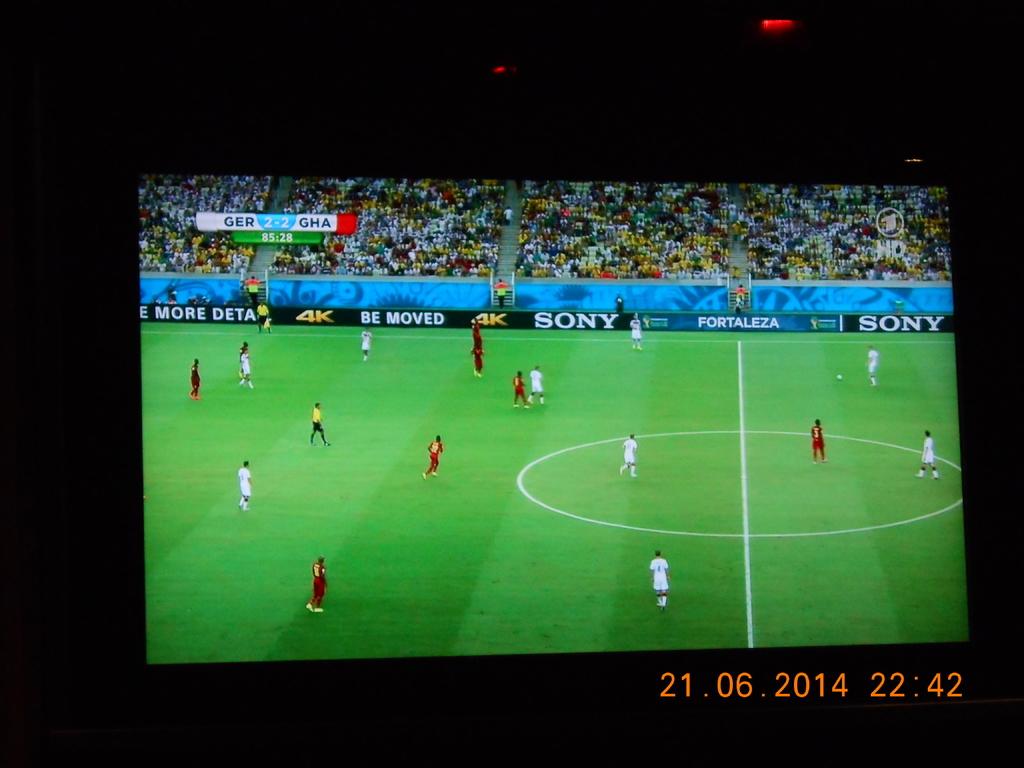What is the name of the company advertised on the far right?
Your response must be concise. Sony. What´s the date on the picture?
Give a very brief answer. 21.06.2014. 